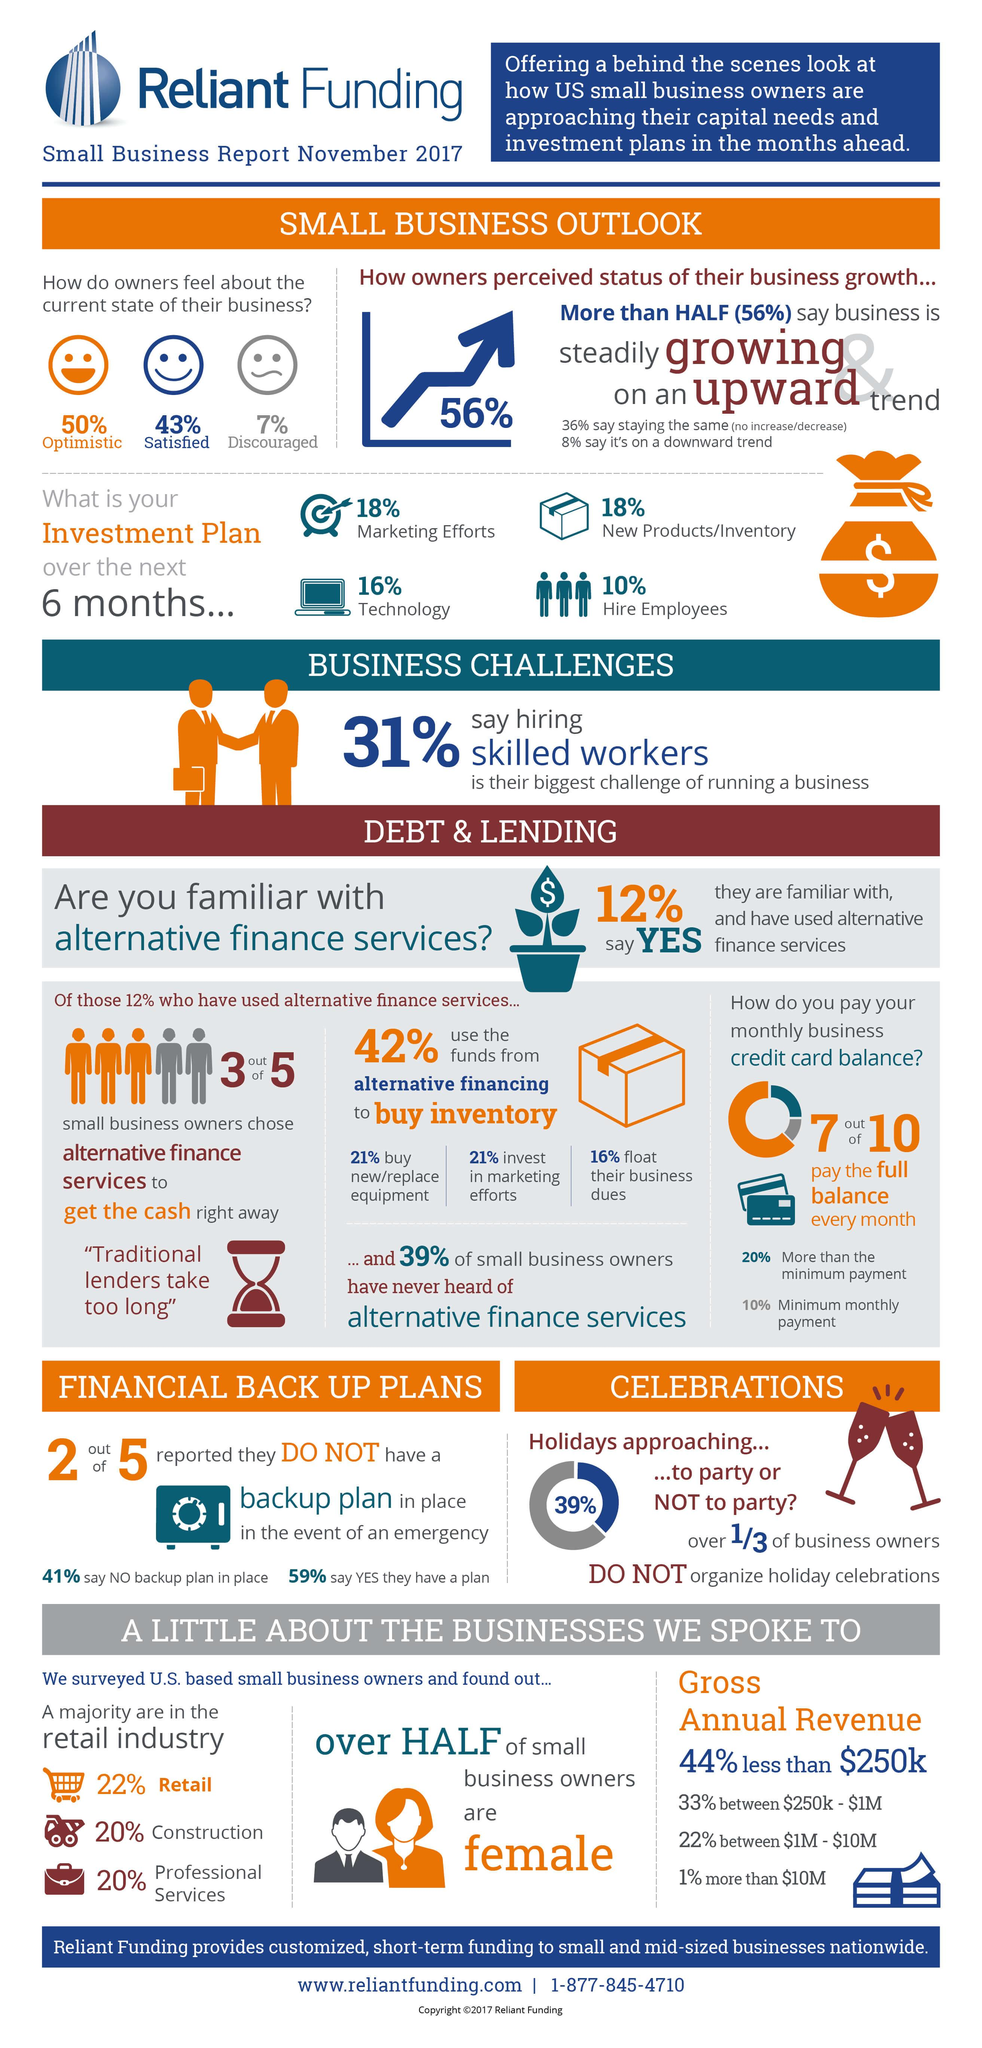Specify some key components in this picture. Approximately 42% of owners in retail and construction are currently represented in the data. According to the survey, 50% of the owners are pessimistic about the future of their business. According to the given data, 57% of owners reported being unsatisfied with their current situation. Out of ten people, three did not pay the full balance every month. Approximately 40% of business owners in professional services and construction are represented in the dataset. 